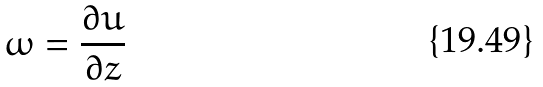Convert formula to latex. <formula><loc_0><loc_0><loc_500><loc_500>\omega = \frac { \partial u } { \partial z }</formula> 